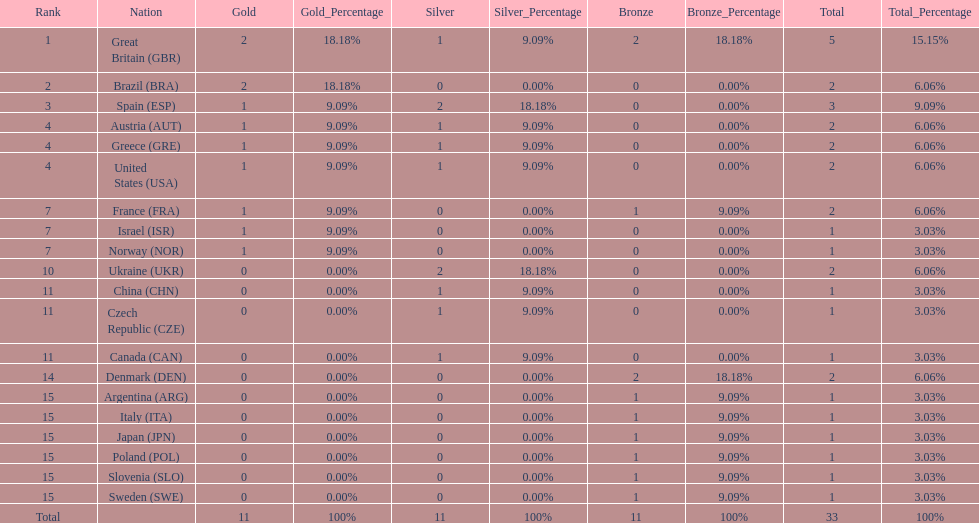How many countries won at least 1 gold and 1 silver medal? 5. 